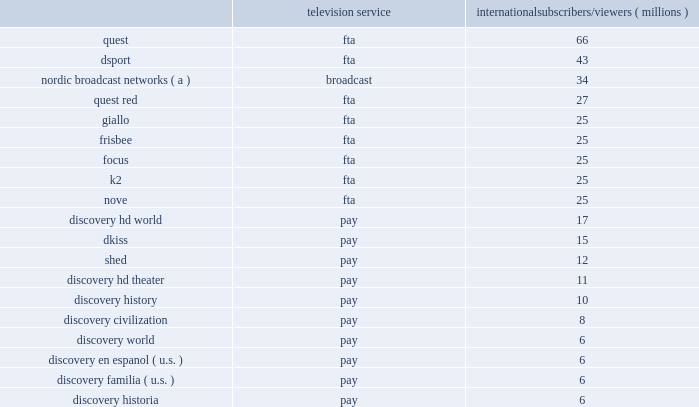Our international networks segment also owns and operates the following regional television networks , which reached the following number of subscribers and viewers via pay and fta or broadcast networks , respectively , as of december 31 , 2017 : television service international subscribers/viewers ( millions ) .
( a ) number of subscribers corresponds to the sum of the subscribers to each of the nordic broadcast networks in sweden , norway , finland and denmark subject to retransmission agreements with pay-tv providers .
The nordic broadcast networks include kanal 5 , kanal 9 , and kanal 11 in sweden , tv norge , max , fem and vox in norway , tv 5 , kutonen , and frii in finland , and kanal 4 , kanal 5 , 6'eren , and canal 9 in denmark .
Similar to u.s .
Networks , a significant source of revenue for international networks relates to fees charged to operators who distribute our linear networks .
Such operators primarily include cable and dth satellite service providers , internet protocol television ( "iptv" ) and over-the-top operators ( "ott" ) .
International television markets vary in their stages of development .
Some markets , such as the u.k. , are more advanced digital television markets , while others remain in the analog environment with varying degrees of investment from operators to expand channel capacity or convert to digital technologies .
Common practice in international markets results in long-term contractual distribution relationships with terms generally shorter than similar customers in the u.s .
Distribution revenue for our international networks segment is largely dependent on the number of subscribers that receive our networks or content , the rates negotiated in the distributor agreements , and the market demand for the content that we provide .
The other significant source of revenue for international networks relates to advertising sold on our television networks and across other distribution platforms , similar to u.s .
Networks .
Advertising revenue is dependent upon a number of factors , including the development of pay and fta television markets , the number of subscribers to and viewers of our channels , viewership demographics , the popularity of our programming , and our ability to sell commercial time over all media platforms .
In certain markets , our advertising sales business operates with in-house sales teams , while we rely on external sales representation services in other markets .
During 2017 , distribution , advertising and other revenues were 57% ( 57 % ) , 41% ( 41 % ) and 2% ( 2 % ) , respectively , of total net revenues for this segment .
While the company has traditionally operated cable networks , in recent years an increasing portion of the company's international advertising revenue is generated by fta or broadcast networks , unlike u.s .
Networks .
During 2017 , fta or broadcast networks generated 54% ( 54 % ) of international networks' advertising revenue and pay-tv networks generated 46% ( 46 % ) of international networks' advertising revenue .
International networks' largest cost is content expense for localized programming disseminated via more than 400 unique distribution feeds .
While our international networks segment maximizes the use of programming from u.s .
Networks , we also develop local programming that is tailored to individual market preferences and license the rights to air films , television series and sporting events from third parties .
International networks amortizes the cost of capitalized content rights based on the proportion of current estimated revenues relative to the estimated remaining total lifetime revenues , which results in either an accelerated method or a straight-line method over the estimated useful lives of the content of up to five years .
Content acquired from u.s .
Networks and content developed locally airing on the same network is amortized similarly , as amortization rates vary by network .
More than half of international networks' content is amortized using an accelerated amortization method , while the remainder is amortized on a straight-line basis .
The costs for multi-year sports programming arrangements are expensed when the event is broadcast based on the estimated relative value of each component of the arrangement .
While international networks and u.s .
Networks have similarities with respect to the nature of operations , the generation of revenue and the categories of expense , international networks have a lower segment margin due to lower economies of scale from being in over 220 markets requiring additional cost for localization to satisfy market variations .
International networks also include sports and fta broadcast channels , which drive higher costs from sports rights and production and investment in broad entertainment programming for broadcast networks .
On june 23 , 2016 , the u.k .
Held a referendum in which voters approved an exit from the european union ( 201ce.u . 201d ) , commonly referred to as 201cbrexit . 201d after a preliminary phase of negotiations towards the end of 2017 , the u.k .
Government and the e.u .
Will in 2018 negotiate the main principles of the u.k . 2019s future relationship with the e.u. , as well as a transitional period .
Brexit may have an adverse impact on advertising , subscribers , distributors and employees , as described in item 1a , risk factors , below .
We continue to monitor the situation and plan for potential effects to our distribution and licensing agreements , unusual foreign currency exchange rate fluctuations , and changes to the legal and regulatory landscape .
Education and other education and other generated revenues of $ 158 million during 2017 , which represented 2% ( 2 % ) of our total consolidated revenues .
Education is comprised of curriculum-based product and service offerings and generates revenues primarily from subscriptions charged to k-12 schools for access to an online suite of curriculum-based vod tools , professional development services , digital textbooks and , to a lesser extent , student assessments and publication of hard copy curriculum-based content .
Other is comprised of our wholly-owned production studio , which provides services to our u.s .
Networks and international networks segments at cost .
On february 26 , 2018 , the company announced the planned sale of a controlling equity stake in its education business in the first half of 2018 , to francisco partners for cash of $ 120 million .
No loss is expected upon sale .
The company will retain an equity interest .
Additionally , the company will have ongoing license agreements which are considered to be at fair value .
As of december 31 , 2017 , the company determined that the education business did not meet the held for sale criteria , as defined in gaap as management had not committed to a plan to sell the assets .
On april 28 , 2017 , the company sold raw and betty to all3media .
All3media is a u.k .
Based television , film and digital production and distribution company .
The company owns 50% ( 50 % ) of all3media and accounts for its investment in all3media under the equity method of accounting .
Raw and betty were components of the studios operating segment reported with education and other .
On november 12 , 2015 , we paid $ 195 million to acquire 5 million shares , or approximately 3% ( 3 % ) , of lions gate entertainment corp .
( "lionsgate" ) , an entertainment company involved in the production of movies and television which is accounted for as an available-for-sale ( "afs" ) security .
During 2016 , we determined that the decline in value of our investment in lionsgate is other- than-temporary in nature and , as such , the cost basis was adjusted to the fair value of the investment as of september 30 , 2016 .
( see note 4 to the accompanying consolidated financial statements. ) content development our content development strategy is designed to increase viewership , maintain innovation and quality leadership , and provide value for our network distributors and advertising customers .
Our content is sourced from a wide range of third-party producers , which include some of the world 2019s leading nonfiction production companies , as well as independent producers and wholly-owned production studios .
Our production arrangements fall into three categories : produced , coproduced and licensed .
Produced content includes content that we engage third parties or wholly owned production studios to develop and produce .
We retain editorial control and own most or all of the rights , in exchange for paying all development and production costs .
Production of digital-first content such as virtual reality and short-form video is typically done through wholly-owned production studios .
Coproduced content refers to program rights on which we have collaborated with third parties to finance and develop either because at times world-wide rights are not available for acquisition or we save costs by collaborating with third parties .
Licensed content is comprised of films or .
How many combined subscribers and viewers in millions do the top 2 pay distributed television services discovery hd world and dkiss have? 
Computations: (17 + 15)
Answer: 32.0. Our international networks segment also owns and operates the following regional television networks , which reached the following number of subscribers and viewers via pay and fta or broadcast networks , respectively , as of december 31 , 2017 : television service international subscribers/viewers ( millions ) .
( a ) number of subscribers corresponds to the sum of the subscribers to each of the nordic broadcast networks in sweden , norway , finland and denmark subject to retransmission agreements with pay-tv providers .
The nordic broadcast networks include kanal 5 , kanal 9 , and kanal 11 in sweden , tv norge , max , fem and vox in norway , tv 5 , kutonen , and frii in finland , and kanal 4 , kanal 5 , 6'eren , and canal 9 in denmark .
Similar to u.s .
Networks , a significant source of revenue for international networks relates to fees charged to operators who distribute our linear networks .
Such operators primarily include cable and dth satellite service providers , internet protocol television ( "iptv" ) and over-the-top operators ( "ott" ) .
International television markets vary in their stages of development .
Some markets , such as the u.k. , are more advanced digital television markets , while others remain in the analog environment with varying degrees of investment from operators to expand channel capacity or convert to digital technologies .
Common practice in international markets results in long-term contractual distribution relationships with terms generally shorter than similar customers in the u.s .
Distribution revenue for our international networks segment is largely dependent on the number of subscribers that receive our networks or content , the rates negotiated in the distributor agreements , and the market demand for the content that we provide .
The other significant source of revenue for international networks relates to advertising sold on our television networks and across other distribution platforms , similar to u.s .
Networks .
Advertising revenue is dependent upon a number of factors , including the development of pay and fta television markets , the number of subscribers to and viewers of our channels , viewership demographics , the popularity of our programming , and our ability to sell commercial time over all media platforms .
In certain markets , our advertising sales business operates with in-house sales teams , while we rely on external sales representation services in other markets .
During 2017 , distribution , advertising and other revenues were 57% ( 57 % ) , 41% ( 41 % ) and 2% ( 2 % ) , respectively , of total net revenues for this segment .
While the company has traditionally operated cable networks , in recent years an increasing portion of the company's international advertising revenue is generated by fta or broadcast networks , unlike u.s .
Networks .
During 2017 , fta or broadcast networks generated 54% ( 54 % ) of international networks' advertising revenue and pay-tv networks generated 46% ( 46 % ) of international networks' advertising revenue .
International networks' largest cost is content expense for localized programming disseminated via more than 400 unique distribution feeds .
While our international networks segment maximizes the use of programming from u.s .
Networks , we also develop local programming that is tailored to individual market preferences and license the rights to air films , television series and sporting events from third parties .
International networks amortizes the cost of capitalized content rights based on the proportion of current estimated revenues relative to the estimated remaining total lifetime revenues , which results in either an accelerated method or a straight-line method over the estimated useful lives of the content of up to five years .
Content acquired from u.s .
Networks and content developed locally airing on the same network is amortized similarly , as amortization rates vary by network .
More than half of international networks' content is amortized using an accelerated amortization method , while the remainder is amortized on a straight-line basis .
The costs for multi-year sports programming arrangements are expensed when the event is broadcast based on the estimated relative value of each component of the arrangement .
While international networks and u.s .
Networks have similarities with respect to the nature of operations , the generation of revenue and the categories of expense , international networks have a lower segment margin due to lower economies of scale from being in over 220 markets requiring additional cost for localization to satisfy market variations .
International networks also include sports and fta broadcast channels , which drive higher costs from sports rights and production and investment in broad entertainment programming for broadcast networks .
On june 23 , 2016 , the u.k .
Held a referendum in which voters approved an exit from the european union ( 201ce.u . 201d ) , commonly referred to as 201cbrexit . 201d after a preliminary phase of negotiations towards the end of 2017 , the u.k .
Government and the e.u .
Will in 2018 negotiate the main principles of the u.k . 2019s future relationship with the e.u. , as well as a transitional period .
Brexit may have an adverse impact on advertising , subscribers , distributors and employees , as described in item 1a , risk factors , below .
We continue to monitor the situation and plan for potential effects to our distribution and licensing agreements , unusual foreign currency exchange rate fluctuations , and changes to the legal and regulatory landscape .
Education and other education and other generated revenues of $ 158 million during 2017 , which represented 2% ( 2 % ) of our total consolidated revenues .
Education is comprised of curriculum-based product and service offerings and generates revenues primarily from subscriptions charged to k-12 schools for access to an online suite of curriculum-based vod tools , professional development services , digital textbooks and , to a lesser extent , student assessments and publication of hard copy curriculum-based content .
Other is comprised of our wholly-owned production studio , which provides services to our u.s .
Networks and international networks segments at cost .
On february 26 , 2018 , the company announced the planned sale of a controlling equity stake in its education business in the first half of 2018 , to francisco partners for cash of $ 120 million .
No loss is expected upon sale .
The company will retain an equity interest .
Additionally , the company will have ongoing license agreements which are considered to be at fair value .
As of december 31 , 2017 , the company determined that the education business did not meet the held for sale criteria , as defined in gaap as management had not committed to a plan to sell the assets .
On april 28 , 2017 , the company sold raw and betty to all3media .
All3media is a u.k .
Based television , film and digital production and distribution company .
The company owns 50% ( 50 % ) of all3media and accounts for its investment in all3media under the equity method of accounting .
Raw and betty were components of the studios operating segment reported with education and other .
On november 12 , 2015 , we paid $ 195 million to acquire 5 million shares , or approximately 3% ( 3 % ) , of lions gate entertainment corp .
( "lionsgate" ) , an entertainment company involved in the production of movies and television which is accounted for as an available-for-sale ( "afs" ) security .
During 2016 , we determined that the decline in value of our investment in lionsgate is other- than-temporary in nature and , as such , the cost basis was adjusted to the fair value of the investment as of september 30 , 2016 .
( see note 4 to the accompanying consolidated financial statements. ) content development our content development strategy is designed to increase viewership , maintain innovation and quality leadership , and provide value for our network distributors and advertising customers .
Our content is sourced from a wide range of third-party producers , which include some of the world 2019s leading nonfiction production companies , as well as independent producers and wholly-owned production studios .
Our production arrangements fall into three categories : produced , coproduced and licensed .
Produced content includes content that we engage third parties or wholly owned production studios to develop and produce .
We retain editorial control and own most or all of the rights , in exchange for paying all development and production costs .
Production of digital-first content such as virtual reality and short-form video is typically done through wholly-owned production studios .
Coproduced content refers to program rights on which we have collaborated with third parties to finance and develop either because at times world-wide rights are not available for acquisition or we save costs by collaborating with third parties .
Licensed content is comprised of films or .
How many combined subscribers and viewers in millions do the top 2 fta distributed television services quest and dsport have? 
Computations: (66 + 43)
Answer: 109.0. 